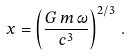Convert formula to latex. <formula><loc_0><loc_0><loc_500><loc_500>x = \left ( \frac { G \, m \, \omega } { c ^ { 3 } } \right ) ^ { 2 / 3 } \, .</formula> 